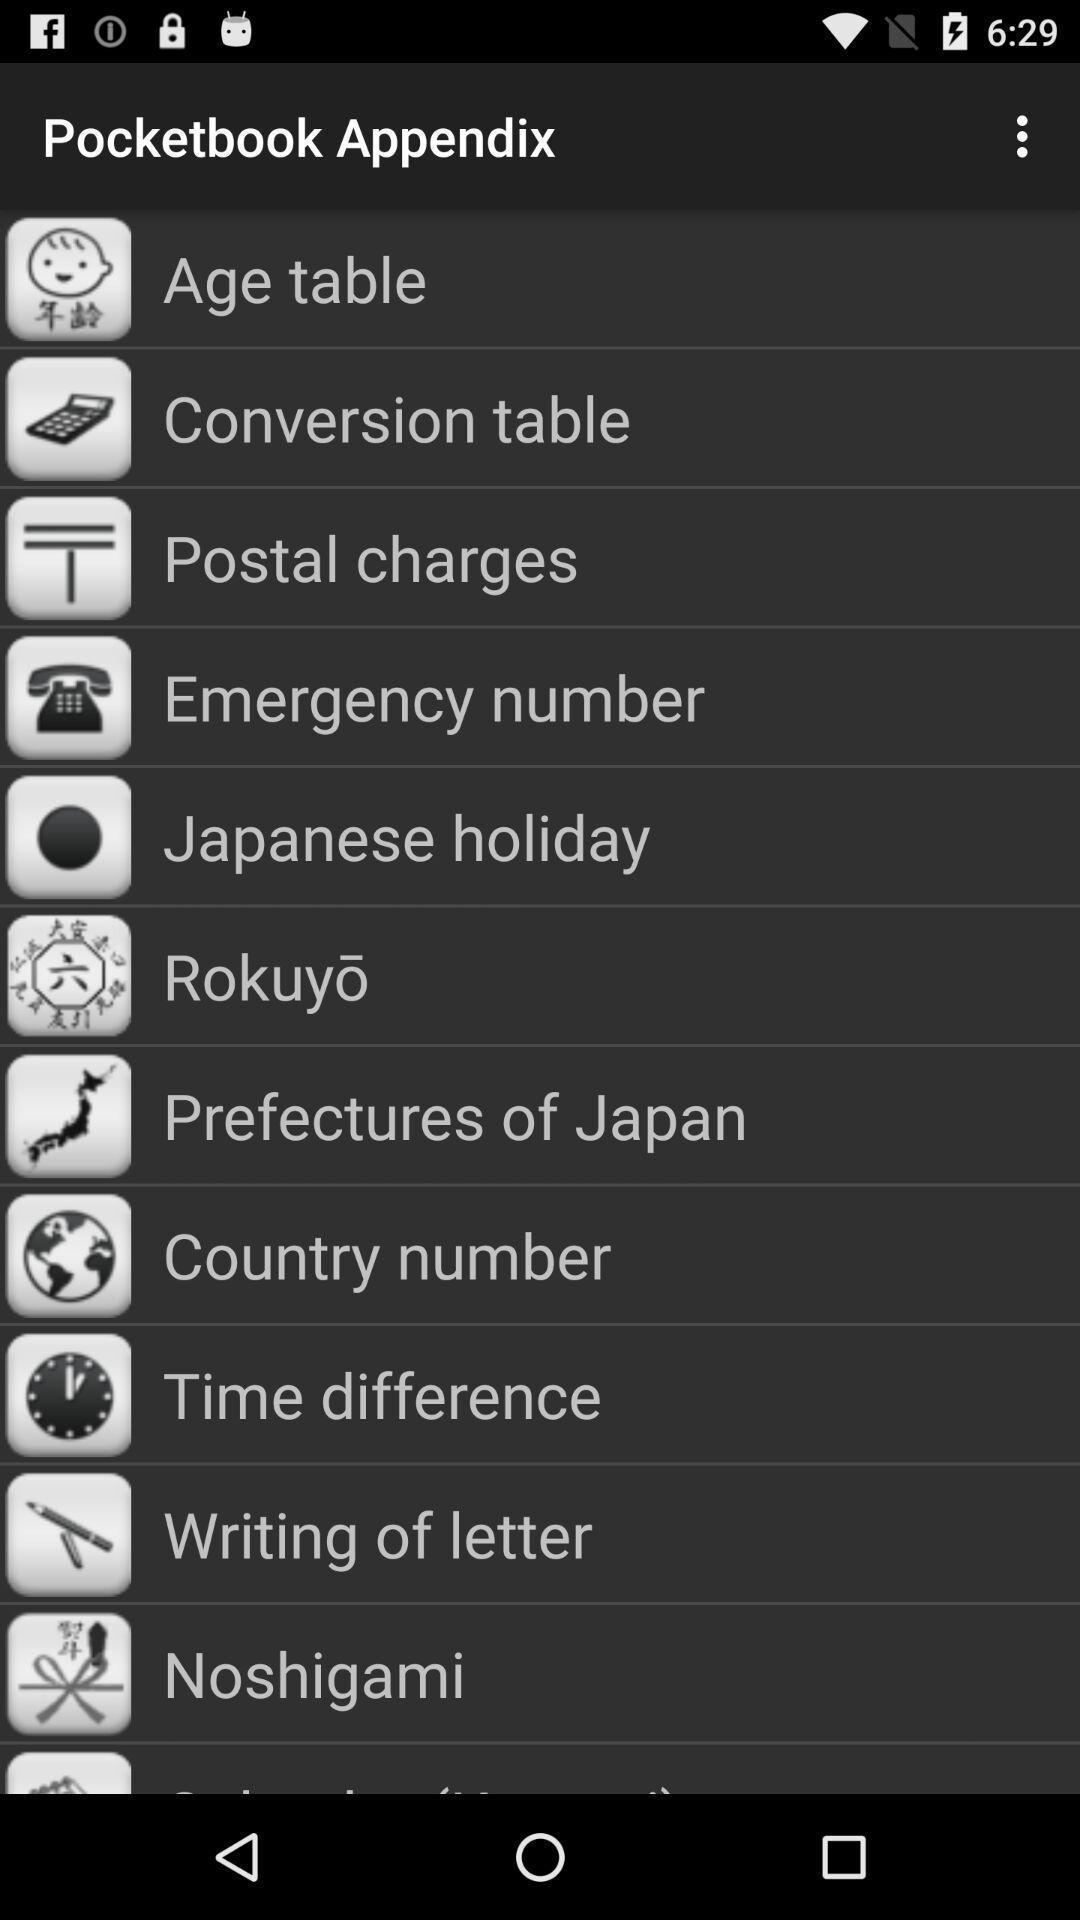What is the overall content of this screenshot? Page showing some pocket book appendix. 